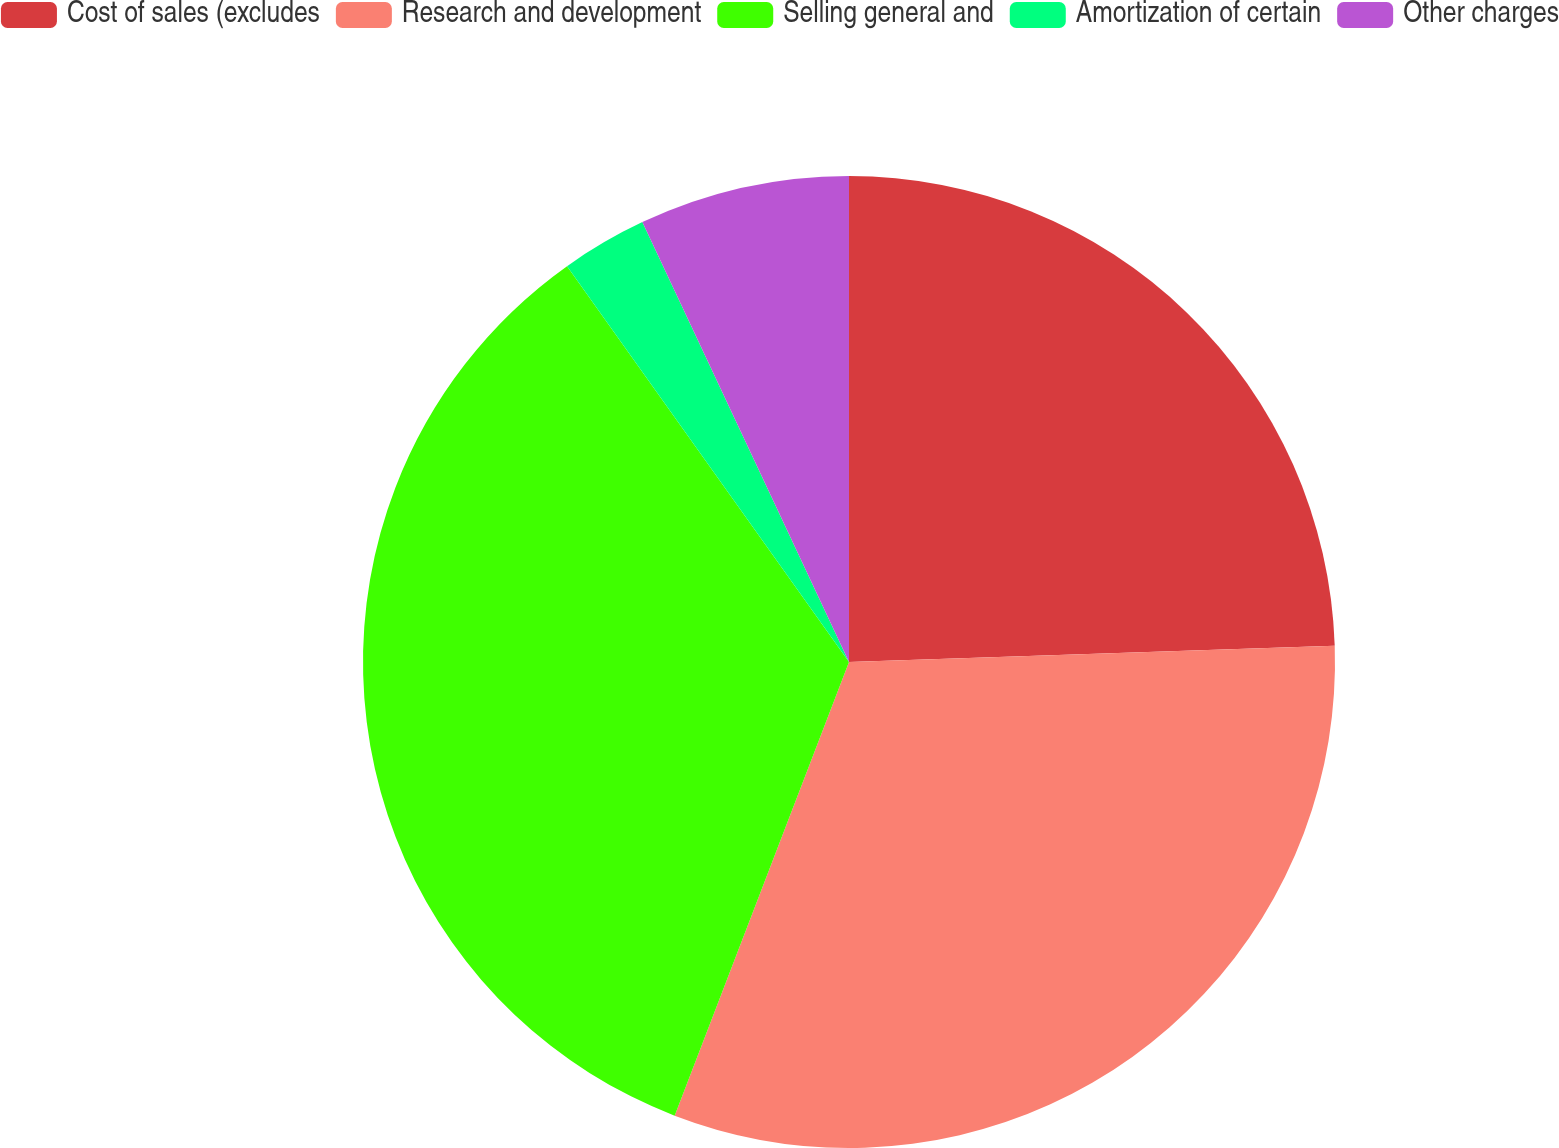Convert chart. <chart><loc_0><loc_0><loc_500><loc_500><pie_chart><fcel>Cost of sales (excludes<fcel>Research and development<fcel>Selling general and<fcel>Amortization of certain<fcel>Other charges<nl><fcel>24.47%<fcel>31.37%<fcel>34.31%<fcel>2.86%<fcel>6.99%<nl></chart> 